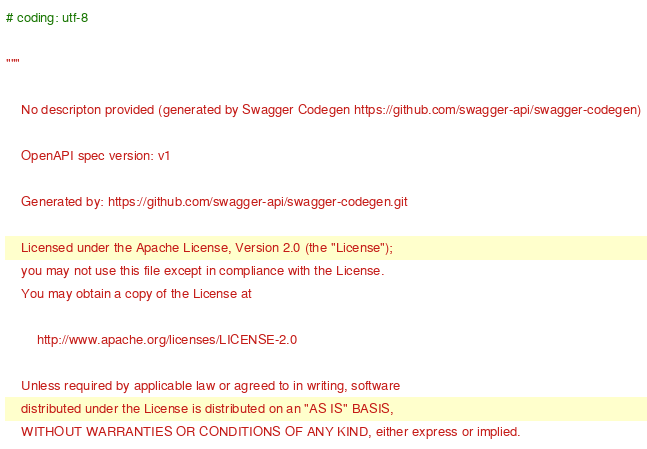<code> <loc_0><loc_0><loc_500><loc_500><_Python_># coding: utf-8

"""

    No descripton provided (generated by Swagger Codegen https://github.com/swagger-api/swagger-codegen)

    OpenAPI spec version: v1
    
    Generated by: https://github.com/swagger-api/swagger-codegen.git

    Licensed under the Apache License, Version 2.0 (the "License");
    you may not use this file except in compliance with the License.
    You may obtain a copy of the License at

        http://www.apache.org/licenses/LICENSE-2.0

    Unless required by applicable law or agreed to in writing, software
    distributed under the License is distributed on an "AS IS" BASIS,
    WITHOUT WARRANTIES OR CONDITIONS OF ANY KIND, either express or implied.</code> 